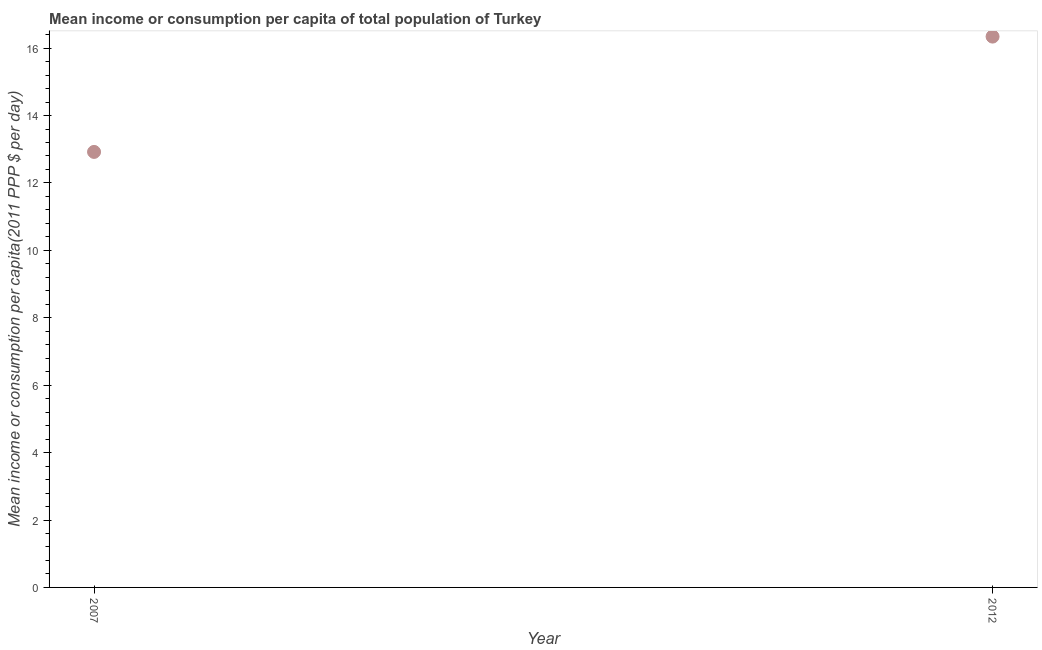What is the mean income or consumption in 2012?
Provide a succinct answer. 16.34. Across all years, what is the maximum mean income or consumption?
Keep it short and to the point. 16.34. Across all years, what is the minimum mean income or consumption?
Make the answer very short. 12.92. In which year was the mean income or consumption maximum?
Your answer should be compact. 2012. What is the sum of the mean income or consumption?
Make the answer very short. 29.26. What is the difference between the mean income or consumption in 2007 and 2012?
Keep it short and to the point. -3.42. What is the average mean income or consumption per year?
Keep it short and to the point. 14.63. What is the median mean income or consumption?
Ensure brevity in your answer.  14.63. Do a majority of the years between 2007 and 2012 (inclusive) have mean income or consumption greater than 11.2 $?
Provide a succinct answer. Yes. What is the ratio of the mean income or consumption in 2007 to that in 2012?
Your response must be concise. 0.79. In how many years, is the mean income or consumption greater than the average mean income or consumption taken over all years?
Offer a terse response. 1. What is the difference between two consecutive major ticks on the Y-axis?
Give a very brief answer. 2. Are the values on the major ticks of Y-axis written in scientific E-notation?
Provide a short and direct response. No. Does the graph contain grids?
Your response must be concise. No. What is the title of the graph?
Provide a succinct answer. Mean income or consumption per capita of total population of Turkey. What is the label or title of the X-axis?
Your answer should be very brief. Year. What is the label or title of the Y-axis?
Keep it short and to the point. Mean income or consumption per capita(2011 PPP $ per day). What is the Mean income or consumption per capita(2011 PPP $ per day) in 2007?
Give a very brief answer. 12.92. What is the Mean income or consumption per capita(2011 PPP $ per day) in 2012?
Your response must be concise. 16.34. What is the difference between the Mean income or consumption per capita(2011 PPP $ per day) in 2007 and 2012?
Offer a very short reply. -3.42. What is the ratio of the Mean income or consumption per capita(2011 PPP $ per day) in 2007 to that in 2012?
Your answer should be very brief. 0.79. 